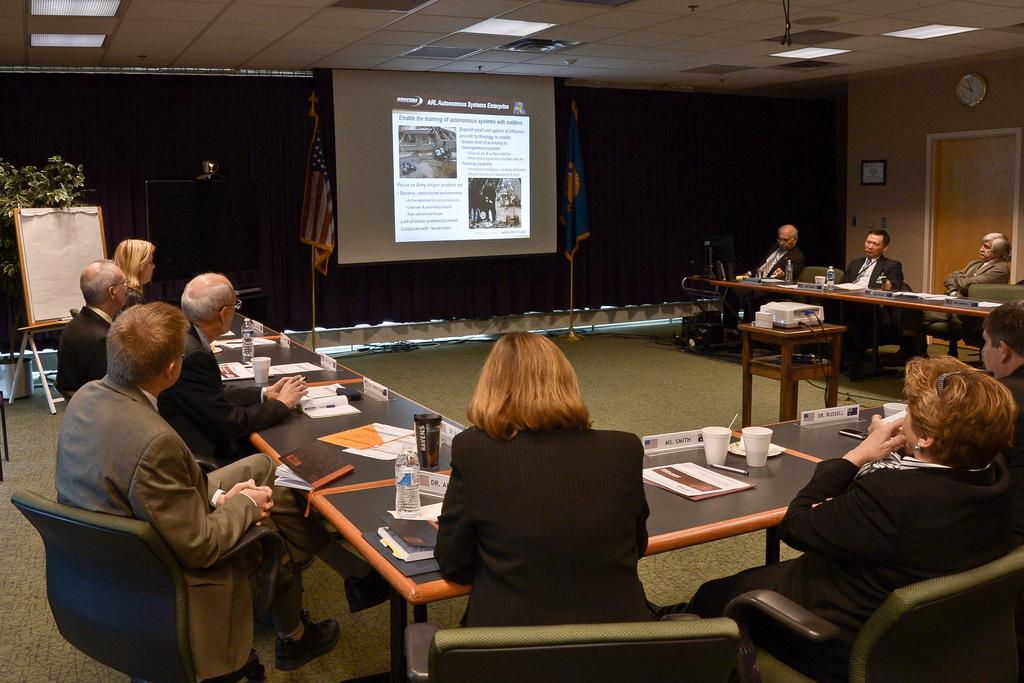What is the main object in the image? There is a screen in the image. What else can be seen in the image? There is a board, people sitting on chairs, a table, bottles, glasses, and papers in the image. What might the people be using the screen and board for? It is not clear from the image what the people are using the screen and board for, but they could be for presenting or discussing information. What is on the table in the image? There are bottles, glasses, and papers on the table in the image. What type of steel is used to construct the chairs in the image? There is no information about the material used to construct the chairs in the image, and therefore we cannot determine if steel is used. 